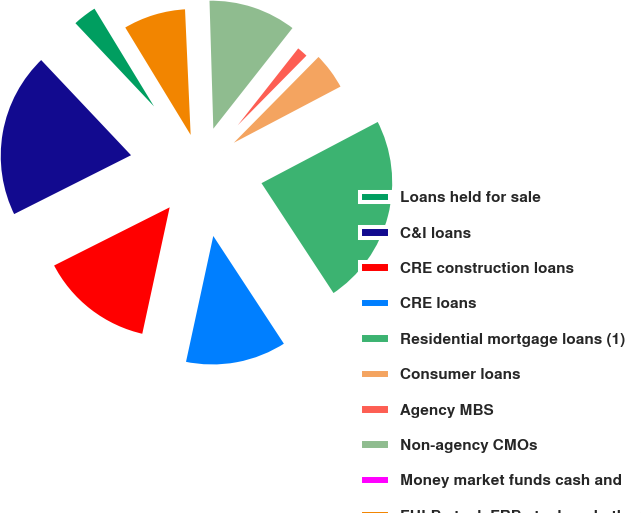Convert chart. <chart><loc_0><loc_0><loc_500><loc_500><pie_chart><fcel>Loans held for sale<fcel>C&I loans<fcel>CRE construction loans<fcel>CRE loans<fcel>Residential mortgage loans (1)<fcel>Consumer loans<fcel>Agency MBS<fcel>Non-agency CMOs<fcel>Money market funds cash and<fcel>FHLB stock FRB stock and other<nl><fcel>3.34%<fcel>20.38%<fcel>14.18%<fcel>12.63%<fcel>23.48%<fcel>4.89%<fcel>1.79%<fcel>11.08%<fcel>0.24%<fcel>7.99%<nl></chart> 